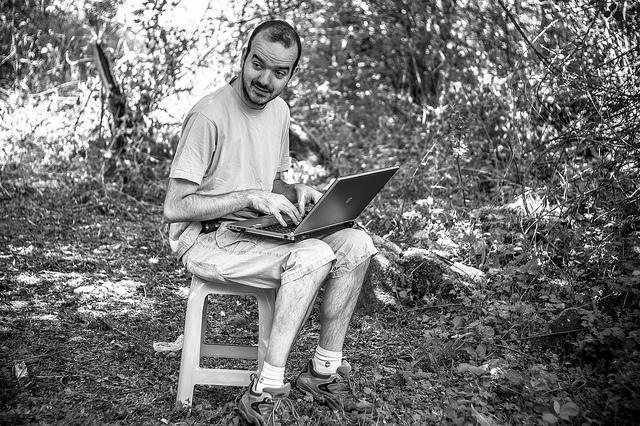How many zebras are there?
Give a very brief answer. 0. 